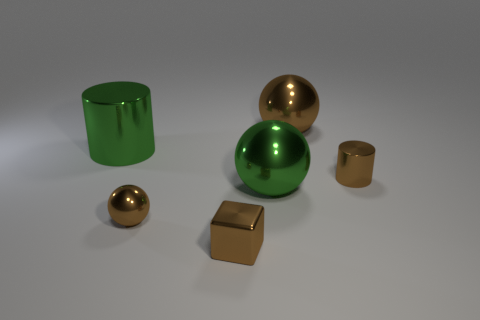What color is the small shiny cube?
Your answer should be very brief. Brown. There is a tiny shiny sphere left of the cylinder in front of the large cylinder; what color is it?
Your answer should be very brief. Brown. Is there a tiny thing that has the same material as the brown cylinder?
Your response must be concise. Yes. What is the material of the tiny object to the right of the brown shiny ball behind the tiny shiny cylinder?
Offer a terse response. Metal. How many small metal objects are the same shape as the large brown shiny thing?
Give a very brief answer. 1. Is the number of large green metal objects less than the number of green metal cylinders?
Offer a very short reply. No. Is there anything else that has the same size as the green cylinder?
Offer a very short reply. Yes. There is another big object that is the same shape as the large brown metal object; what material is it?
Offer a very short reply. Metal. Is the number of tiny brown shiny blocks greater than the number of yellow metallic cubes?
Ensure brevity in your answer.  Yes. How many other things are there of the same color as the cube?
Provide a succinct answer. 3. 